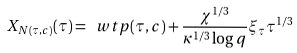<formula> <loc_0><loc_0><loc_500><loc_500>X _ { N ( \tau , c ) } ( \tau ) = \ w t p ( \tau , c ) + \frac { \chi ^ { 1 / 3 } } { \kappa ^ { 1 / 3 } \log q } \xi _ { \tau } \tau ^ { 1 / 3 }</formula> 